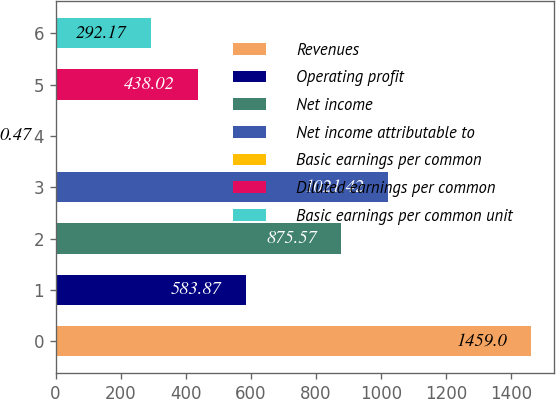<chart> <loc_0><loc_0><loc_500><loc_500><bar_chart><fcel>Revenues<fcel>Operating profit<fcel>Net income<fcel>Net income attributable to<fcel>Basic earnings per common<fcel>Diluted earnings per common<fcel>Basic earnings per common unit<nl><fcel>1459<fcel>583.87<fcel>875.57<fcel>1021.42<fcel>0.47<fcel>438.02<fcel>292.17<nl></chart> 